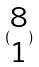Convert formula to latex. <formula><loc_0><loc_0><loc_500><loc_500>( \begin{matrix} 8 \\ 1 \end{matrix} )</formula> 